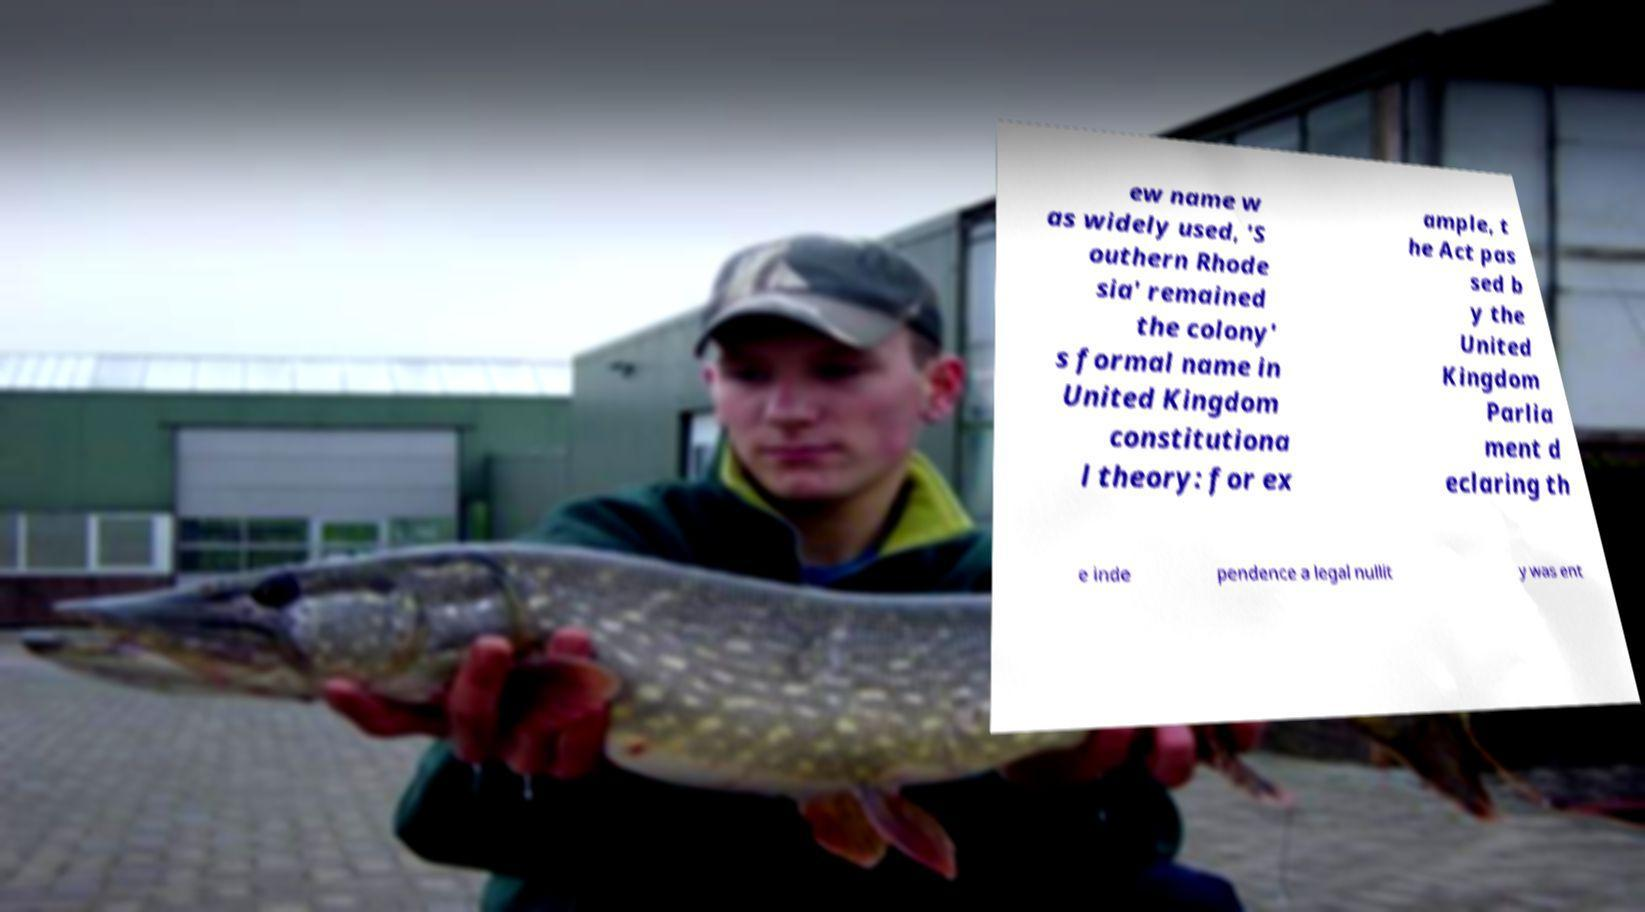There's text embedded in this image that I need extracted. Can you transcribe it verbatim? ew name w as widely used, 'S outhern Rhode sia' remained the colony' s formal name in United Kingdom constitutiona l theory: for ex ample, t he Act pas sed b y the United Kingdom Parlia ment d eclaring th e inde pendence a legal nullit y was ent 